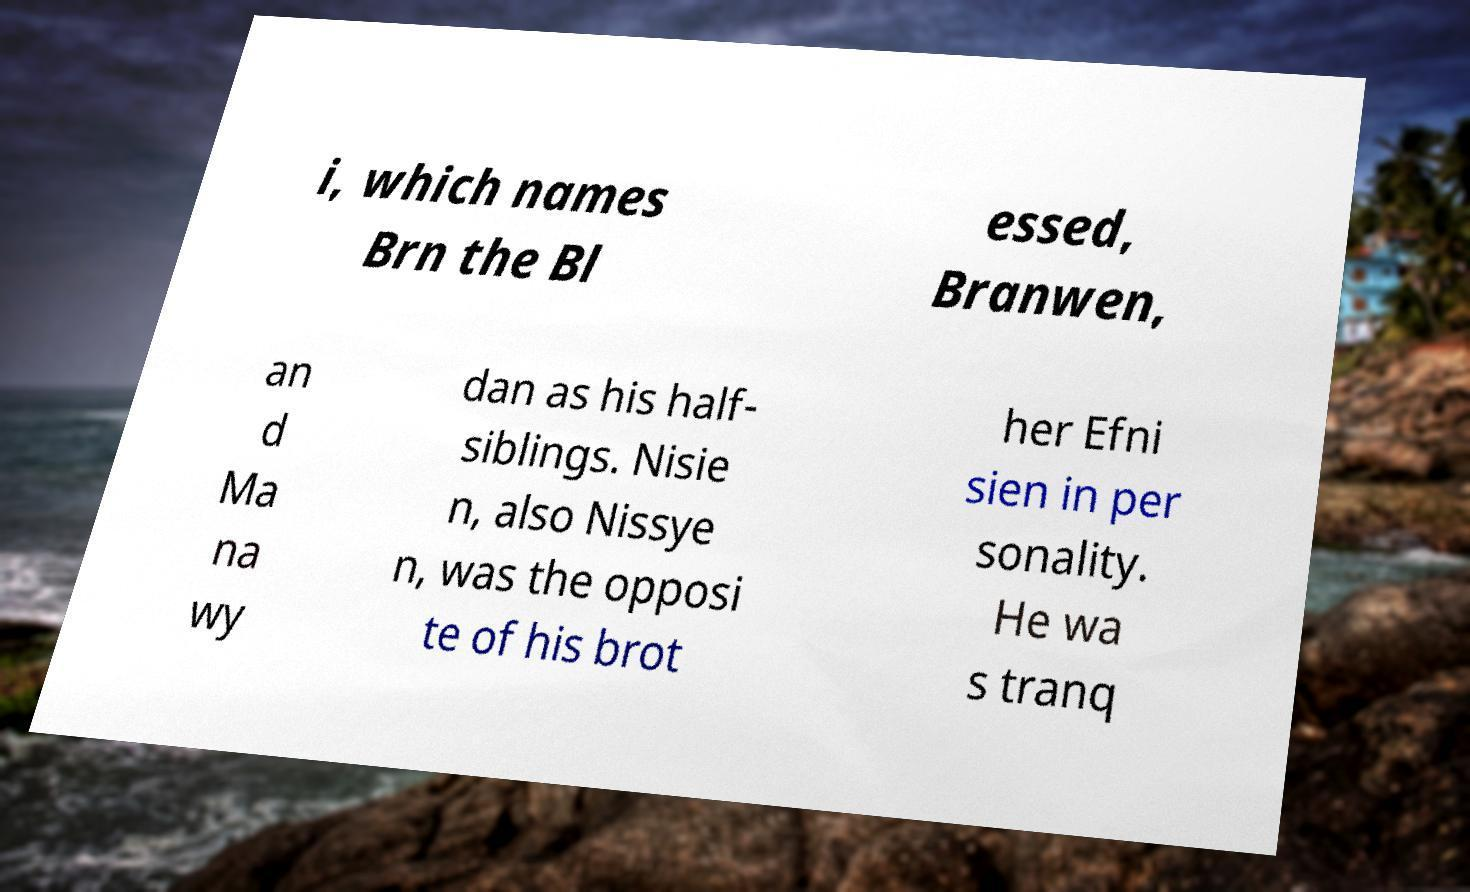Please identify and transcribe the text found in this image. i, which names Brn the Bl essed, Branwen, an d Ma na wy dan as his half- siblings. Nisie n, also Nissye n, was the opposi te of his brot her Efni sien in per sonality. He wa s tranq 